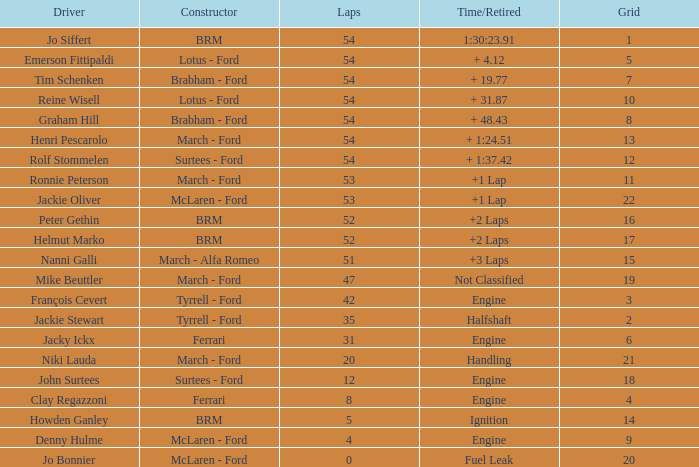Could you parse the entire table as a dict? {'header': ['Driver', 'Constructor', 'Laps', 'Time/Retired', 'Grid'], 'rows': [['Jo Siffert', 'BRM', '54', '1:30:23.91', '1'], ['Emerson Fittipaldi', 'Lotus - Ford', '54', '+ 4.12', '5'], ['Tim Schenken', 'Brabham - Ford', '54', '+ 19.77', '7'], ['Reine Wisell', 'Lotus - Ford', '54', '+ 31.87', '10'], ['Graham Hill', 'Brabham - Ford', '54', '+ 48.43', '8'], ['Henri Pescarolo', 'March - Ford', '54', '+ 1:24.51', '13'], ['Rolf Stommelen', 'Surtees - Ford', '54', '+ 1:37.42', '12'], ['Ronnie Peterson', 'March - Ford', '53', '+1 Lap', '11'], ['Jackie Oliver', 'McLaren - Ford', '53', '+1 Lap', '22'], ['Peter Gethin', 'BRM', '52', '+2 Laps', '16'], ['Helmut Marko', 'BRM', '52', '+2 Laps', '17'], ['Nanni Galli', 'March - Alfa Romeo', '51', '+3 Laps', '15'], ['Mike Beuttler', 'March - Ford', '47', 'Not Classified', '19'], ['François Cevert', 'Tyrrell - Ford', '42', 'Engine', '3'], ['Jackie Stewart', 'Tyrrell - Ford', '35', 'Halfshaft', '2'], ['Jacky Ickx', 'Ferrari', '31', 'Engine', '6'], ['Niki Lauda', 'March - Ford', '20', 'Handling', '21'], ['John Surtees', 'Surtees - Ford', '12', 'Engine', '18'], ['Clay Regazzoni', 'Ferrari', '8', 'Engine', '4'], ['Howden Ganley', 'BRM', '5', 'Ignition', '14'], ['Denny Hulme', 'McLaren - Ford', '4', 'Engine', '9'], ['Jo Bonnier', 'McLaren - Ford', '0', 'Fuel Leak', '20']]} What is the low grid that has brm and over 54 laps? None. 